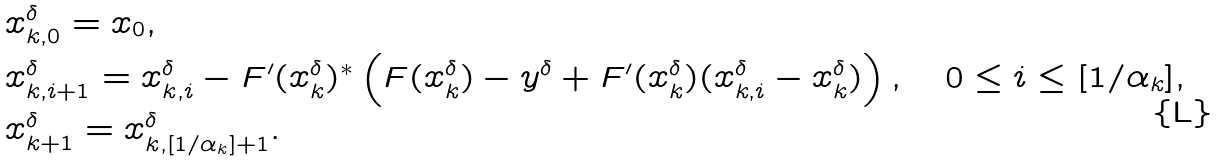<formula> <loc_0><loc_0><loc_500><loc_500>& x _ { k , 0 } ^ { \delta } = x _ { 0 } , \\ & x _ { k , i + 1 } ^ { \delta } = x _ { k , i } ^ { \delta } - F ^ { \prime } ( x _ { k } ^ { \delta } ) ^ { * } \left ( F ( x _ { k } ^ { \delta } ) - y ^ { \delta } + F ^ { \prime } ( x _ { k } ^ { \delta } ) ( x _ { k , i } ^ { \delta } - x _ { k } ^ { \delta } ) \right ) , \quad 0 \leq i \leq [ 1 / \alpha _ { k } ] , \\ & x _ { k + 1 } ^ { \delta } = x _ { k , [ 1 / \alpha _ { k } ] + 1 } ^ { \delta } .</formula> 